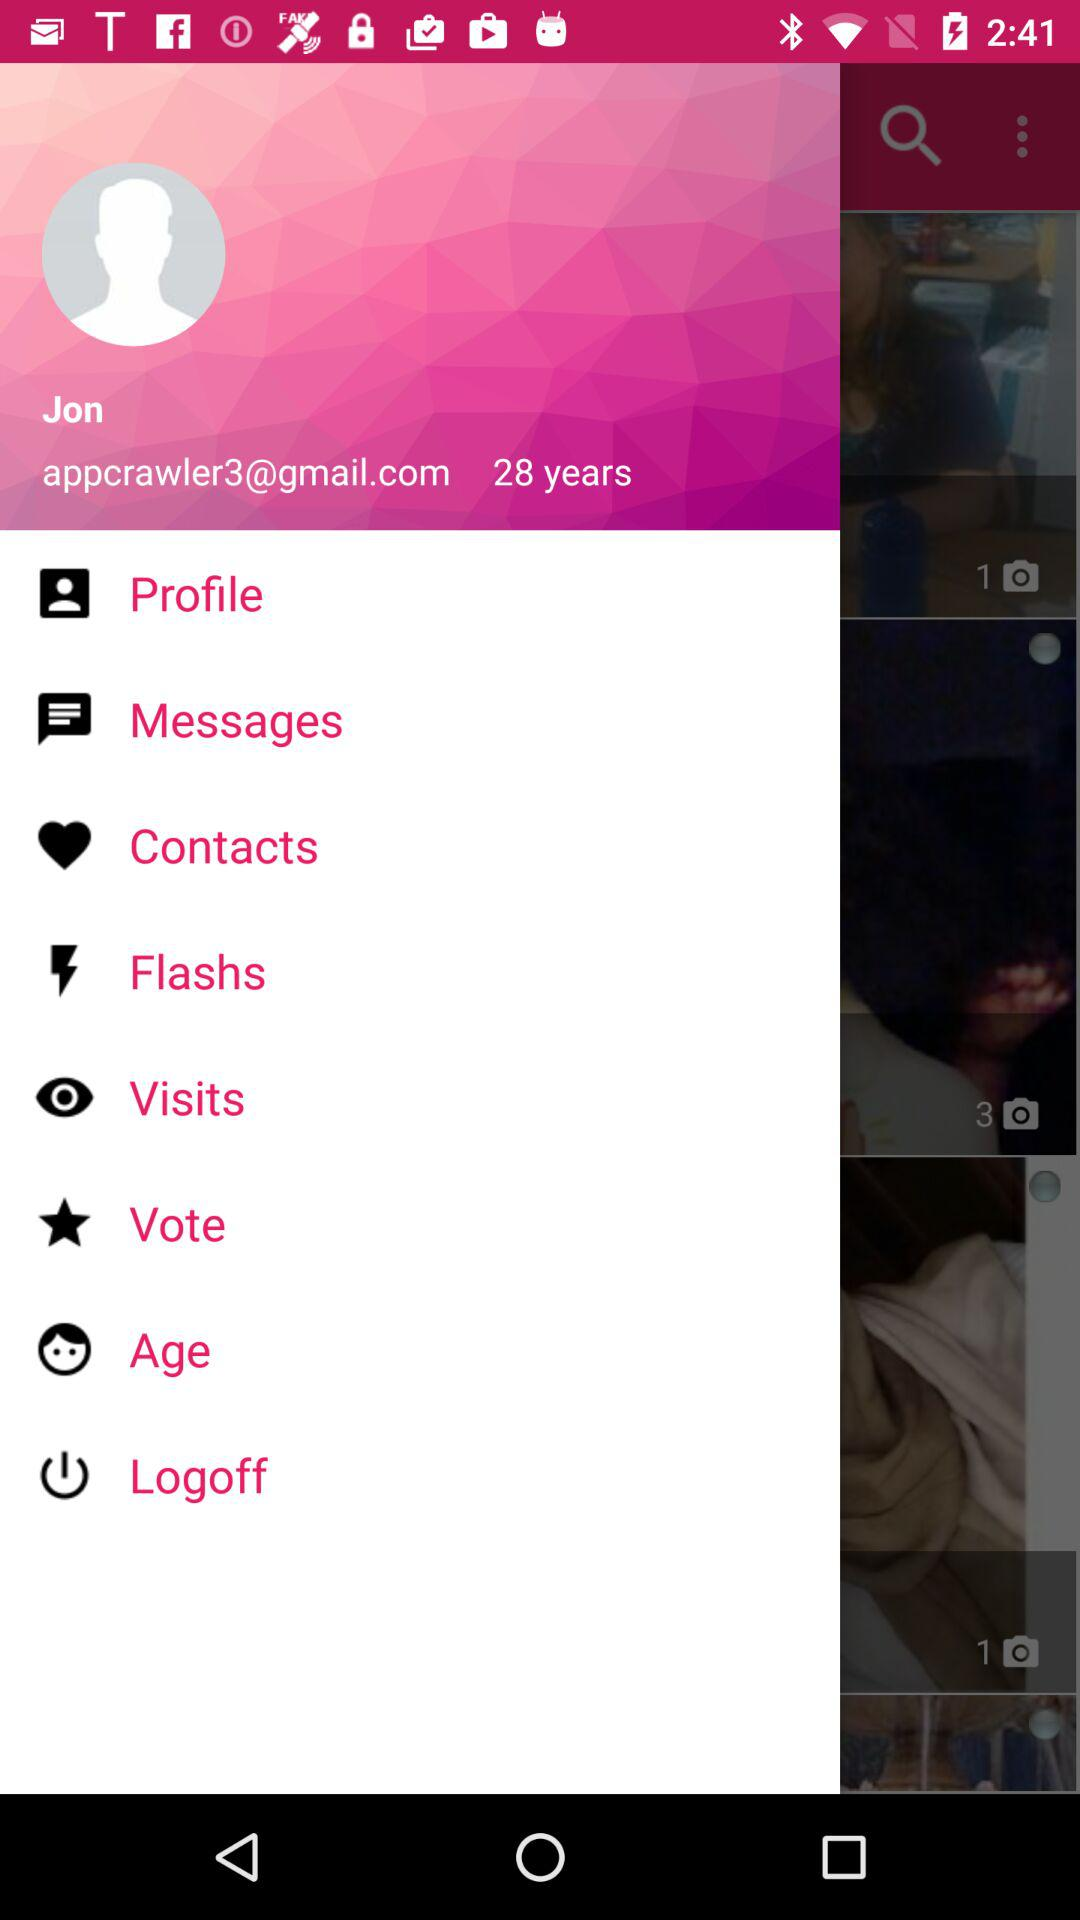What is the user name? The user name is Jon. 